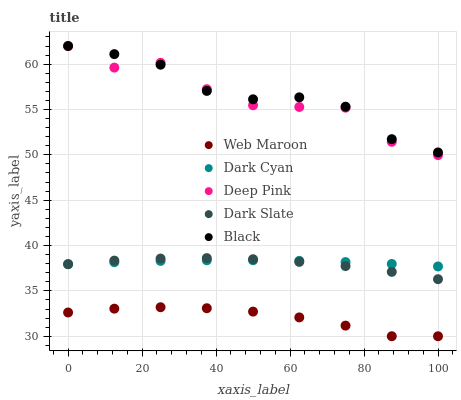Does Web Maroon have the minimum area under the curve?
Answer yes or no. Yes. Does Black have the maximum area under the curve?
Answer yes or no. Yes. Does Dark Slate have the minimum area under the curve?
Answer yes or no. No. Does Dark Slate have the maximum area under the curve?
Answer yes or no. No. Is Dark Cyan the smoothest?
Answer yes or no. Yes. Is Deep Pink the roughest?
Answer yes or no. Yes. Is Dark Slate the smoothest?
Answer yes or no. No. Is Dark Slate the roughest?
Answer yes or no. No. Does Web Maroon have the lowest value?
Answer yes or no. Yes. Does Dark Slate have the lowest value?
Answer yes or no. No. Does Black have the highest value?
Answer yes or no. Yes. Does Dark Slate have the highest value?
Answer yes or no. No. Is Dark Cyan less than Black?
Answer yes or no. Yes. Is Dark Cyan greater than Web Maroon?
Answer yes or no. Yes. Does Dark Slate intersect Dark Cyan?
Answer yes or no. Yes. Is Dark Slate less than Dark Cyan?
Answer yes or no. No. Is Dark Slate greater than Dark Cyan?
Answer yes or no. No. Does Dark Cyan intersect Black?
Answer yes or no. No. 